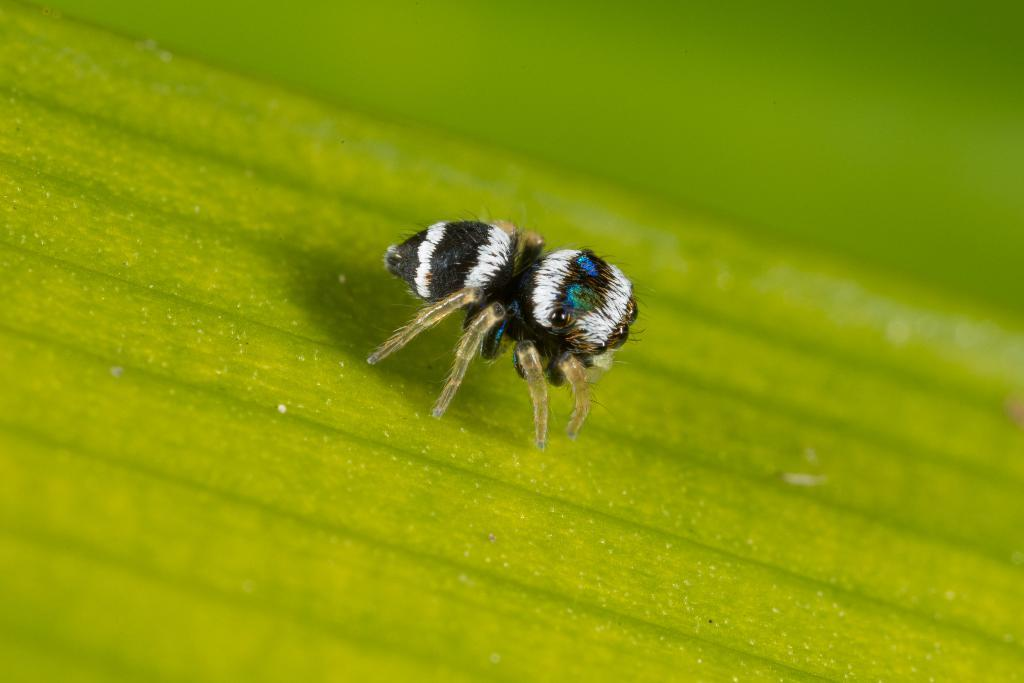What type of creature can be seen in the image? There is an insect in the image. Where is the insect located in the image? The insect is on a surface. What books are on the shelf in the image? There is no shelf or books present in the image; it only features an insect on a surface. 